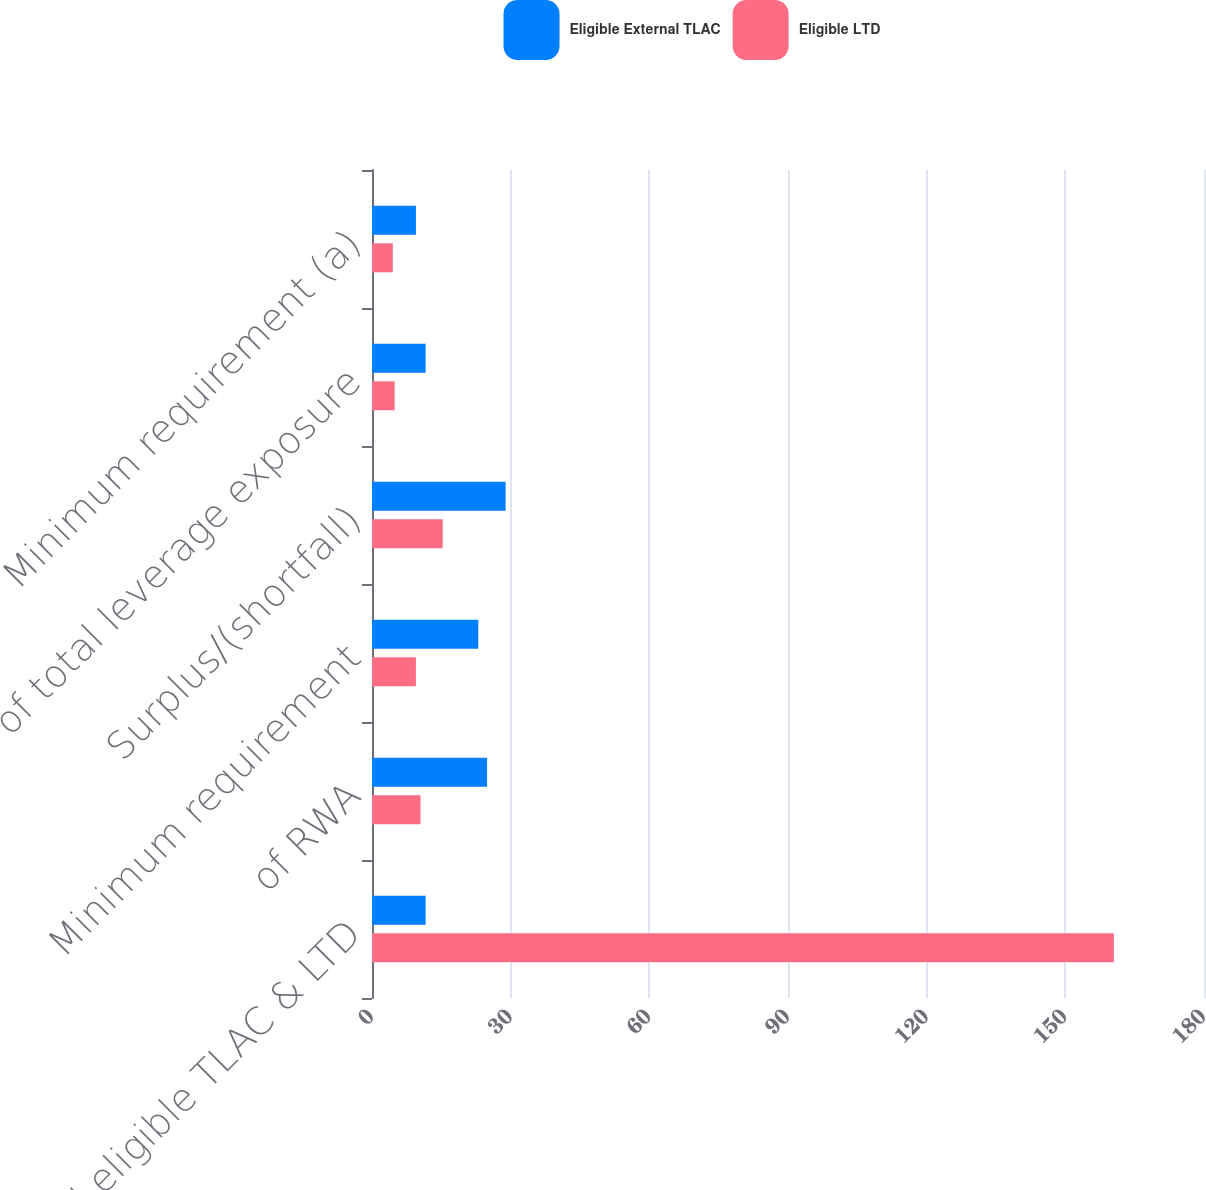Convert chart. <chart><loc_0><loc_0><loc_500><loc_500><stacked_bar_chart><ecel><fcel>Total eligible TLAC & LTD<fcel>of RWA<fcel>Minimum requirement<fcel>Surplus/(shortfall)<fcel>of total leverage exposure<fcel>Minimum requirement (a)<nl><fcel>Eligible External TLAC<fcel>11.6<fcel>24.9<fcel>23<fcel>28.9<fcel>11.6<fcel>9.5<nl><fcel>Eligible LTD<fcel>160.5<fcel>10.5<fcel>9.5<fcel>15.3<fcel>4.9<fcel>4.5<nl></chart> 